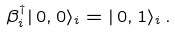<formula> <loc_0><loc_0><loc_500><loc_500>\beta ^ { \dagger } _ { i } | \, 0 , 0 \rangle _ { i } = | \, 0 , 1 \rangle _ { i } \, .</formula> 